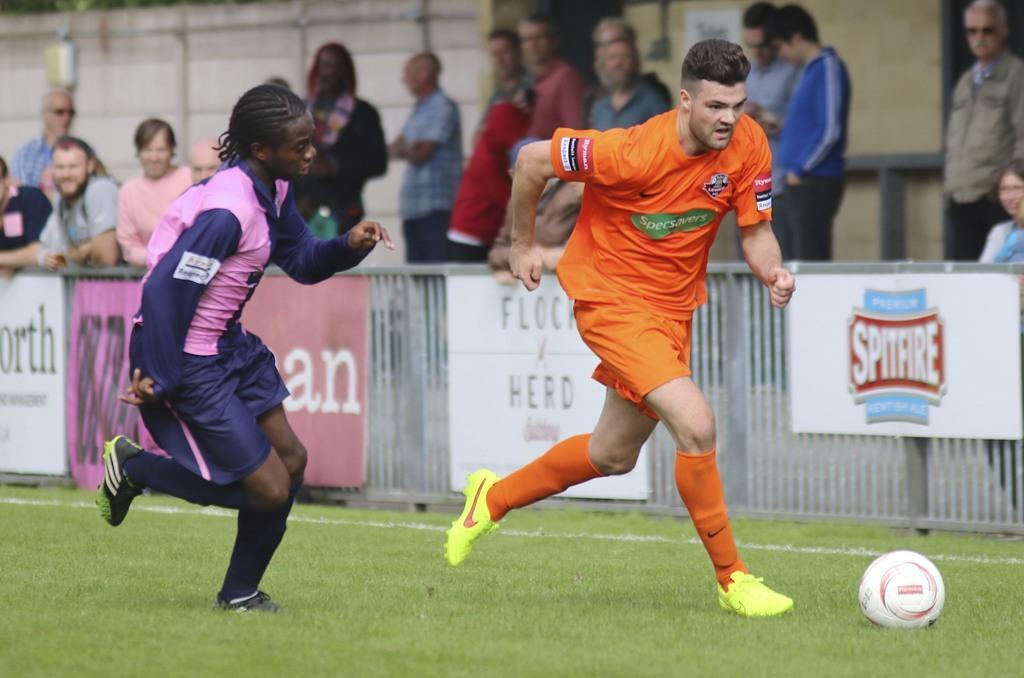Please provide a concise description of this image. In this image two persons are running on the grassland. There is a football on the land. There is a person wearing a orange shirt. Behind him there is a fence having few banners attached to it. Behind it there are few persons standing. Left side there is a person wearing pink and blue shirt. 